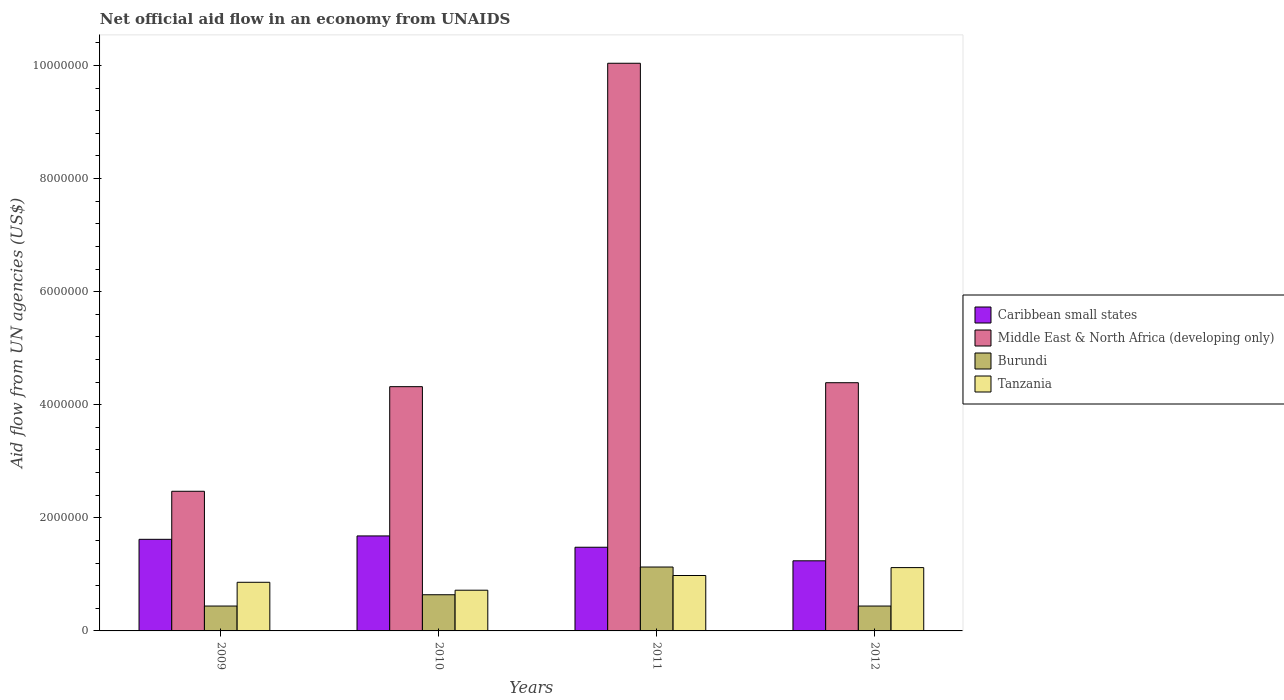How many different coloured bars are there?
Keep it short and to the point. 4. How many bars are there on the 3rd tick from the left?
Provide a succinct answer. 4. What is the net official aid flow in Tanzania in 2010?
Give a very brief answer. 7.20e+05. Across all years, what is the maximum net official aid flow in Burundi?
Make the answer very short. 1.13e+06. Across all years, what is the minimum net official aid flow in Tanzania?
Give a very brief answer. 7.20e+05. What is the total net official aid flow in Caribbean small states in the graph?
Give a very brief answer. 6.02e+06. What is the difference between the net official aid flow in Tanzania in 2011 and that in 2012?
Provide a short and direct response. -1.40e+05. What is the difference between the net official aid flow in Caribbean small states in 2009 and the net official aid flow in Tanzania in 2012?
Give a very brief answer. 5.00e+05. What is the average net official aid flow in Caribbean small states per year?
Give a very brief answer. 1.50e+06. In the year 2011, what is the difference between the net official aid flow in Caribbean small states and net official aid flow in Tanzania?
Ensure brevity in your answer.  5.00e+05. What is the ratio of the net official aid flow in Middle East & North Africa (developing only) in 2011 to that in 2012?
Give a very brief answer. 2.29. What is the difference between the highest and the lowest net official aid flow in Burundi?
Keep it short and to the point. 6.90e+05. In how many years, is the net official aid flow in Middle East & North Africa (developing only) greater than the average net official aid flow in Middle East & North Africa (developing only) taken over all years?
Give a very brief answer. 1. What does the 2nd bar from the left in 2011 represents?
Offer a very short reply. Middle East & North Africa (developing only). What does the 1st bar from the right in 2009 represents?
Make the answer very short. Tanzania. Is it the case that in every year, the sum of the net official aid flow in Middle East & North Africa (developing only) and net official aid flow in Tanzania is greater than the net official aid flow in Burundi?
Provide a succinct answer. Yes. How many years are there in the graph?
Keep it short and to the point. 4. Are the values on the major ticks of Y-axis written in scientific E-notation?
Give a very brief answer. No. How many legend labels are there?
Offer a very short reply. 4. How are the legend labels stacked?
Provide a succinct answer. Vertical. What is the title of the graph?
Your answer should be very brief. Net official aid flow in an economy from UNAIDS. What is the label or title of the Y-axis?
Ensure brevity in your answer.  Aid flow from UN agencies (US$). What is the Aid flow from UN agencies (US$) of Caribbean small states in 2009?
Make the answer very short. 1.62e+06. What is the Aid flow from UN agencies (US$) of Middle East & North Africa (developing only) in 2009?
Give a very brief answer. 2.47e+06. What is the Aid flow from UN agencies (US$) in Tanzania in 2009?
Your response must be concise. 8.60e+05. What is the Aid flow from UN agencies (US$) in Caribbean small states in 2010?
Offer a terse response. 1.68e+06. What is the Aid flow from UN agencies (US$) in Middle East & North Africa (developing only) in 2010?
Your answer should be very brief. 4.32e+06. What is the Aid flow from UN agencies (US$) in Burundi in 2010?
Keep it short and to the point. 6.40e+05. What is the Aid flow from UN agencies (US$) in Tanzania in 2010?
Provide a short and direct response. 7.20e+05. What is the Aid flow from UN agencies (US$) in Caribbean small states in 2011?
Your answer should be very brief. 1.48e+06. What is the Aid flow from UN agencies (US$) of Middle East & North Africa (developing only) in 2011?
Give a very brief answer. 1.00e+07. What is the Aid flow from UN agencies (US$) of Burundi in 2011?
Your answer should be compact. 1.13e+06. What is the Aid flow from UN agencies (US$) of Tanzania in 2011?
Your answer should be compact. 9.80e+05. What is the Aid flow from UN agencies (US$) of Caribbean small states in 2012?
Your response must be concise. 1.24e+06. What is the Aid flow from UN agencies (US$) of Middle East & North Africa (developing only) in 2012?
Offer a very short reply. 4.39e+06. What is the Aid flow from UN agencies (US$) in Tanzania in 2012?
Make the answer very short. 1.12e+06. Across all years, what is the maximum Aid flow from UN agencies (US$) in Caribbean small states?
Provide a succinct answer. 1.68e+06. Across all years, what is the maximum Aid flow from UN agencies (US$) of Middle East & North Africa (developing only)?
Offer a very short reply. 1.00e+07. Across all years, what is the maximum Aid flow from UN agencies (US$) in Burundi?
Give a very brief answer. 1.13e+06. Across all years, what is the maximum Aid flow from UN agencies (US$) in Tanzania?
Your answer should be compact. 1.12e+06. Across all years, what is the minimum Aid flow from UN agencies (US$) in Caribbean small states?
Your response must be concise. 1.24e+06. Across all years, what is the minimum Aid flow from UN agencies (US$) of Middle East & North Africa (developing only)?
Offer a terse response. 2.47e+06. Across all years, what is the minimum Aid flow from UN agencies (US$) in Burundi?
Provide a short and direct response. 4.40e+05. Across all years, what is the minimum Aid flow from UN agencies (US$) of Tanzania?
Provide a succinct answer. 7.20e+05. What is the total Aid flow from UN agencies (US$) of Caribbean small states in the graph?
Offer a terse response. 6.02e+06. What is the total Aid flow from UN agencies (US$) of Middle East & North Africa (developing only) in the graph?
Ensure brevity in your answer.  2.12e+07. What is the total Aid flow from UN agencies (US$) of Burundi in the graph?
Provide a succinct answer. 2.65e+06. What is the total Aid flow from UN agencies (US$) of Tanzania in the graph?
Offer a very short reply. 3.68e+06. What is the difference between the Aid flow from UN agencies (US$) of Middle East & North Africa (developing only) in 2009 and that in 2010?
Your answer should be compact. -1.85e+06. What is the difference between the Aid flow from UN agencies (US$) of Middle East & North Africa (developing only) in 2009 and that in 2011?
Make the answer very short. -7.57e+06. What is the difference between the Aid flow from UN agencies (US$) of Burundi in 2009 and that in 2011?
Ensure brevity in your answer.  -6.90e+05. What is the difference between the Aid flow from UN agencies (US$) of Tanzania in 2009 and that in 2011?
Provide a succinct answer. -1.20e+05. What is the difference between the Aid flow from UN agencies (US$) in Caribbean small states in 2009 and that in 2012?
Keep it short and to the point. 3.80e+05. What is the difference between the Aid flow from UN agencies (US$) in Middle East & North Africa (developing only) in 2009 and that in 2012?
Make the answer very short. -1.92e+06. What is the difference between the Aid flow from UN agencies (US$) in Caribbean small states in 2010 and that in 2011?
Ensure brevity in your answer.  2.00e+05. What is the difference between the Aid flow from UN agencies (US$) of Middle East & North Africa (developing only) in 2010 and that in 2011?
Ensure brevity in your answer.  -5.72e+06. What is the difference between the Aid flow from UN agencies (US$) of Burundi in 2010 and that in 2011?
Offer a terse response. -4.90e+05. What is the difference between the Aid flow from UN agencies (US$) of Middle East & North Africa (developing only) in 2010 and that in 2012?
Your answer should be very brief. -7.00e+04. What is the difference between the Aid flow from UN agencies (US$) of Tanzania in 2010 and that in 2012?
Keep it short and to the point. -4.00e+05. What is the difference between the Aid flow from UN agencies (US$) of Middle East & North Africa (developing only) in 2011 and that in 2012?
Offer a terse response. 5.65e+06. What is the difference between the Aid flow from UN agencies (US$) of Burundi in 2011 and that in 2012?
Your answer should be compact. 6.90e+05. What is the difference between the Aid flow from UN agencies (US$) of Tanzania in 2011 and that in 2012?
Make the answer very short. -1.40e+05. What is the difference between the Aid flow from UN agencies (US$) in Caribbean small states in 2009 and the Aid flow from UN agencies (US$) in Middle East & North Africa (developing only) in 2010?
Provide a short and direct response. -2.70e+06. What is the difference between the Aid flow from UN agencies (US$) in Caribbean small states in 2009 and the Aid flow from UN agencies (US$) in Burundi in 2010?
Give a very brief answer. 9.80e+05. What is the difference between the Aid flow from UN agencies (US$) in Caribbean small states in 2009 and the Aid flow from UN agencies (US$) in Tanzania in 2010?
Offer a terse response. 9.00e+05. What is the difference between the Aid flow from UN agencies (US$) of Middle East & North Africa (developing only) in 2009 and the Aid flow from UN agencies (US$) of Burundi in 2010?
Keep it short and to the point. 1.83e+06. What is the difference between the Aid flow from UN agencies (US$) in Middle East & North Africa (developing only) in 2009 and the Aid flow from UN agencies (US$) in Tanzania in 2010?
Your answer should be compact. 1.75e+06. What is the difference between the Aid flow from UN agencies (US$) in Burundi in 2009 and the Aid flow from UN agencies (US$) in Tanzania in 2010?
Make the answer very short. -2.80e+05. What is the difference between the Aid flow from UN agencies (US$) in Caribbean small states in 2009 and the Aid flow from UN agencies (US$) in Middle East & North Africa (developing only) in 2011?
Provide a succinct answer. -8.42e+06. What is the difference between the Aid flow from UN agencies (US$) of Caribbean small states in 2009 and the Aid flow from UN agencies (US$) of Tanzania in 2011?
Your answer should be very brief. 6.40e+05. What is the difference between the Aid flow from UN agencies (US$) of Middle East & North Africa (developing only) in 2009 and the Aid flow from UN agencies (US$) of Burundi in 2011?
Make the answer very short. 1.34e+06. What is the difference between the Aid flow from UN agencies (US$) of Middle East & North Africa (developing only) in 2009 and the Aid flow from UN agencies (US$) of Tanzania in 2011?
Ensure brevity in your answer.  1.49e+06. What is the difference between the Aid flow from UN agencies (US$) in Burundi in 2009 and the Aid flow from UN agencies (US$) in Tanzania in 2011?
Make the answer very short. -5.40e+05. What is the difference between the Aid flow from UN agencies (US$) of Caribbean small states in 2009 and the Aid flow from UN agencies (US$) of Middle East & North Africa (developing only) in 2012?
Keep it short and to the point. -2.77e+06. What is the difference between the Aid flow from UN agencies (US$) of Caribbean small states in 2009 and the Aid flow from UN agencies (US$) of Burundi in 2012?
Provide a succinct answer. 1.18e+06. What is the difference between the Aid flow from UN agencies (US$) of Middle East & North Africa (developing only) in 2009 and the Aid flow from UN agencies (US$) of Burundi in 2012?
Make the answer very short. 2.03e+06. What is the difference between the Aid flow from UN agencies (US$) of Middle East & North Africa (developing only) in 2009 and the Aid flow from UN agencies (US$) of Tanzania in 2012?
Your answer should be very brief. 1.35e+06. What is the difference between the Aid flow from UN agencies (US$) in Burundi in 2009 and the Aid flow from UN agencies (US$) in Tanzania in 2012?
Your answer should be very brief. -6.80e+05. What is the difference between the Aid flow from UN agencies (US$) of Caribbean small states in 2010 and the Aid flow from UN agencies (US$) of Middle East & North Africa (developing only) in 2011?
Give a very brief answer. -8.36e+06. What is the difference between the Aid flow from UN agencies (US$) in Caribbean small states in 2010 and the Aid flow from UN agencies (US$) in Burundi in 2011?
Offer a terse response. 5.50e+05. What is the difference between the Aid flow from UN agencies (US$) in Middle East & North Africa (developing only) in 2010 and the Aid flow from UN agencies (US$) in Burundi in 2011?
Your answer should be compact. 3.19e+06. What is the difference between the Aid flow from UN agencies (US$) of Middle East & North Africa (developing only) in 2010 and the Aid flow from UN agencies (US$) of Tanzania in 2011?
Give a very brief answer. 3.34e+06. What is the difference between the Aid flow from UN agencies (US$) in Caribbean small states in 2010 and the Aid flow from UN agencies (US$) in Middle East & North Africa (developing only) in 2012?
Provide a short and direct response. -2.71e+06. What is the difference between the Aid flow from UN agencies (US$) in Caribbean small states in 2010 and the Aid flow from UN agencies (US$) in Burundi in 2012?
Your answer should be compact. 1.24e+06. What is the difference between the Aid flow from UN agencies (US$) in Caribbean small states in 2010 and the Aid flow from UN agencies (US$) in Tanzania in 2012?
Provide a succinct answer. 5.60e+05. What is the difference between the Aid flow from UN agencies (US$) in Middle East & North Africa (developing only) in 2010 and the Aid flow from UN agencies (US$) in Burundi in 2012?
Keep it short and to the point. 3.88e+06. What is the difference between the Aid flow from UN agencies (US$) in Middle East & North Africa (developing only) in 2010 and the Aid flow from UN agencies (US$) in Tanzania in 2012?
Your answer should be compact. 3.20e+06. What is the difference between the Aid flow from UN agencies (US$) in Burundi in 2010 and the Aid flow from UN agencies (US$) in Tanzania in 2012?
Make the answer very short. -4.80e+05. What is the difference between the Aid flow from UN agencies (US$) of Caribbean small states in 2011 and the Aid flow from UN agencies (US$) of Middle East & North Africa (developing only) in 2012?
Make the answer very short. -2.91e+06. What is the difference between the Aid flow from UN agencies (US$) in Caribbean small states in 2011 and the Aid flow from UN agencies (US$) in Burundi in 2012?
Make the answer very short. 1.04e+06. What is the difference between the Aid flow from UN agencies (US$) of Middle East & North Africa (developing only) in 2011 and the Aid flow from UN agencies (US$) of Burundi in 2012?
Keep it short and to the point. 9.60e+06. What is the difference between the Aid flow from UN agencies (US$) of Middle East & North Africa (developing only) in 2011 and the Aid flow from UN agencies (US$) of Tanzania in 2012?
Your answer should be very brief. 8.92e+06. What is the difference between the Aid flow from UN agencies (US$) of Burundi in 2011 and the Aid flow from UN agencies (US$) of Tanzania in 2012?
Your answer should be compact. 10000. What is the average Aid flow from UN agencies (US$) of Caribbean small states per year?
Give a very brief answer. 1.50e+06. What is the average Aid flow from UN agencies (US$) of Middle East & North Africa (developing only) per year?
Provide a succinct answer. 5.30e+06. What is the average Aid flow from UN agencies (US$) of Burundi per year?
Your answer should be compact. 6.62e+05. What is the average Aid flow from UN agencies (US$) in Tanzania per year?
Your answer should be compact. 9.20e+05. In the year 2009, what is the difference between the Aid flow from UN agencies (US$) in Caribbean small states and Aid flow from UN agencies (US$) in Middle East & North Africa (developing only)?
Ensure brevity in your answer.  -8.50e+05. In the year 2009, what is the difference between the Aid flow from UN agencies (US$) of Caribbean small states and Aid flow from UN agencies (US$) of Burundi?
Your response must be concise. 1.18e+06. In the year 2009, what is the difference between the Aid flow from UN agencies (US$) in Caribbean small states and Aid flow from UN agencies (US$) in Tanzania?
Keep it short and to the point. 7.60e+05. In the year 2009, what is the difference between the Aid flow from UN agencies (US$) in Middle East & North Africa (developing only) and Aid flow from UN agencies (US$) in Burundi?
Your response must be concise. 2.03e+06. In the year 2009, what is the difference between the Aid flow from UN agencies (US$) of Middle East & North Africa (developing only) and Aid flow from UN agencies (US$) of Tanzania?
Keep it short and to the point. 1.61e+06. In the year 2009, what is the difference between the Aid flow from UN agencies (US$) in Burundi and Aid flow from UN agencies (US$) in Tanzania?
Provide a succinct answer. -4.20e+05. In the year 2010, what is the difference between the Aid flow from UN agencies (US$) of Caribbean small states and Aid flow from UN agencies (US$) of Middle East & North Africa (developing only)?
Your response must be concise. -2.64e+06. In the year 2010, what is the difference between the Aid flow from UN agencies (US$) of Caribbean small states and Aid flow from UN agencies (US$) of Burundi?
Offer a very short reply. 1.04e+06. In the year 2010, what is the difference between the Aid flow from UN agencies (US$) of Caribbean small states and Aid flow from UN agencies (US$) of Tanzania?
Provide a succinct answer. 9.60e+05. In the year 2010, what is the difference between the Aid flow from UN agencies (US$) of Middle East & North Africa (developing only) and Aid flow from UN agencies (US$) of Burundi?
Ensure brevity in your answer.  3.68e+06. In the year 2010, what is the difference between the Aid flow from UN agencies (US$) of Middle East & North Africa (developing only) and Aid flow from UN agencies (US$) of Tanzania?
Provide a succinct answer. 3.60e+06. In the year 2011, what is the difference between the Aid flow from UN agencies (US$) of Caribbean small states and Aid flow from UN agencies (US$) of Middle East & North Africa (developing only)?
Keep it short and to the point. -8.56e+06. In the year 2011, what is the difference between the Aid flow from UN agencies (US$) in Caribbean small states and Aid flow from UN agencies (US$) in Burundi?
Make the answer very short. 3.50e+05. In the year 2011, what is the difference between the Aid flow from UN agencies (US$) of Caribbean small states and Aid flow from UN agencies (US$) of Tanzania?
Ensure brevity in your answer.  5.00e+05. In the year 2011, what is the difference between the Aid flow from UN agencies (US$) of Middle East & North Africa (developing only) and Aid flow from UN agencies (US$) of Burundi?
Make the answer very short. 8.91e+06. In the year 2011, what is the difference between the Aid flow from UN agencies (US$) of Middle East & North Africa (developing only) and Aid flow from UN agencies (US$) of Tanzania?
Your answer should be compact. 9.06e+06. In the year 2011, what is the difference between the Aid flow from UN agencies (US$) in Burundi and Aid flow from UN agencies (US$) in Tanzania?
Keep it short and to the point. 1.50e+05. In the year 2012, what is the difference between the Aid flow from UN agencies (US$) of Caribbean small states and Aid flow from UN agencies (US$) of Middle East & North Africa (developing only)?
Give a very brief answer. -3.15e+06. In the year 2012, what is the difference between the Aid flow from UN agencies (US$) in Caribbean small states and Aid flow from UN agencies (US$) in Burundi?
Your response must be concise. 8.00e+05. In the year 2012, what is the difference between the Aid flow from UN agencies (US$) of Caribbean small states and Aid flow from UN agencies (US$) of Tanzania?
Offer a very short reply. 1.20e+05. In the year 2012, what is the difference between the Aid flow from UN agencies (US$) in Middle East & North Africa (developing only) and Aid flow from UN agencies (US$) in Burundi?
Your answer should be compact. 3.95e+06. In the year 2012, what is the difference between the Aid flow from UN agencies (US$) of Middle East & North Africa (developing only) and Aid flow from UN agencies (US$) of Tanzania?
Ensure brevity in your answer.  3.27e+06. In the year 2012, what is the difference between the Aid flow from UN agencies (US$) in Burundi and Aid flow from UN agencies (US$) in Tanzania?
Give a very brief answer. -6.80e+05. What is the ratio of the Aid flow from UN agencies (US$) in Middle East & North Africa (developing only) in 2009 to that in 2010?
Ensure brevity in your answer.  0.57. What is the ratio of the Aid flow from UN agencies (US$) in Burundi in 2009 to that in 2010?
Give a very brief answer. 0.69. What is the ratio of the Aid flow from UN agencies (US$) of Tanzania in 2009 to that in 2010?
Keep it short and to the point. 1.19. What is the ratio of the Aid flow from UN agencies (US$) in Caribbean small states in 2009 to that in 2011?
Your response must be concise. 1.09. What is the ratio of the Aid flow from UN agencies (US$) of Middle East & North Africa (developing only) in 2009 to that in 2011?
Ensure brevity in your answer.  0.25. What is the ratio of the Aid flow from UN agencies (US$) of Burundi in 2009 to that in 2011?
Your answer should be compact. 0.39. What is the ratio of the Aid flow from UN agencies (US$) in Tanzania in 2009 to that in 2011?
Offer a very short reply. 0.88. What is the ratio of the Aid flow from UN agencies (US$) of Caribbean small states in 2009 to that in 2012?
Make the answer very short. 1.31. What is the ratio of the Aid flow from UN agencies (US$) in Middle East & North Africa (developing only) in 2009 to that in 2012?
Offer a very short reply. 0.56. What is the ratio of the Aid flow from UN agencies (US$) in Tanzania in 2009 to that in 2012?
Ensure brevity in your answer.  0.77. What is the ratio of the Aid flow from UN agencies (US$) in Caribbean small states in 2010 to that in 2011?
Make the answer very short. 1.14. What is the ratio of the Aid flow from UN agencies (US$) in Middle East & North Africa (developing only) in 2010 to that in 2011?
Offer a very short reply. 0.43. What is the ratio of the Aid flow from UN agencies (US$) of Burundi in 2010 to that in 2011?
Provide a short and direct response. 0.57. What is the ratio of the Aid flow from UN agencies (US$) in Tanzania in 2010 to that in 2011?
Give a very brief answer. 0.73. What is the ratio of the Aid flow from UN agencies (US$) in Caribbean small states in 2010 to that in 2012?
Offer a terse response. 1.35. What is the ratio of the Aid flow from UN agencies (US$) in Middle East & North Africa (developing only) in 2010 to that in 2012?
Your answer should be very brief. 0.98. What is the ratio of the Aid flow from UN agencies (US$) in Burundi in 2010 to that in 2012?
Keep it short and to the point. 1.45. What is the ratio of the Aid flow from UN agencies (US$) of Tanzania in 2010 to that in 2012?
Offer a very short reply. 0.64. What is the ratio of the Aid flow from UN agencies (US$) of Caribbean small states in 2011 to that in 2012?
Provide a succinct answer. 1.19. What is the ratio of the Aid flow from UN agencies (US$) of Middle East & North Africa (developing only) in 2011 to that in 2012?
Offer a very short reply. 2.29. What is the ratio of the Aid flow from UN agencies (US$) of Burundi in 2011 to that in 2012?
Provide a succinct answer. 2.57. What is the difference between the highest and the second highest Aid flow from UN agencies (US$) of Middle East & North Africa (developing only)?
Provide a succinct answer. 5.65e+06. What is the difference between the highest and the second highest Aid flow from UN agencies (US$) in Tanzania?
Ensure brevity in your answer.  1.40e+05. What is the difference between the highest and the lowest Aid flow from UN agencies (US$) in Middle East & North Africa (developing only)?
Provide a short and direct response. 7.57e+06. What is the difference between the highest and the lowest Aid flow from UN agencies (US$) of Burundi?
Make the answer very short. 6.90e+05. 